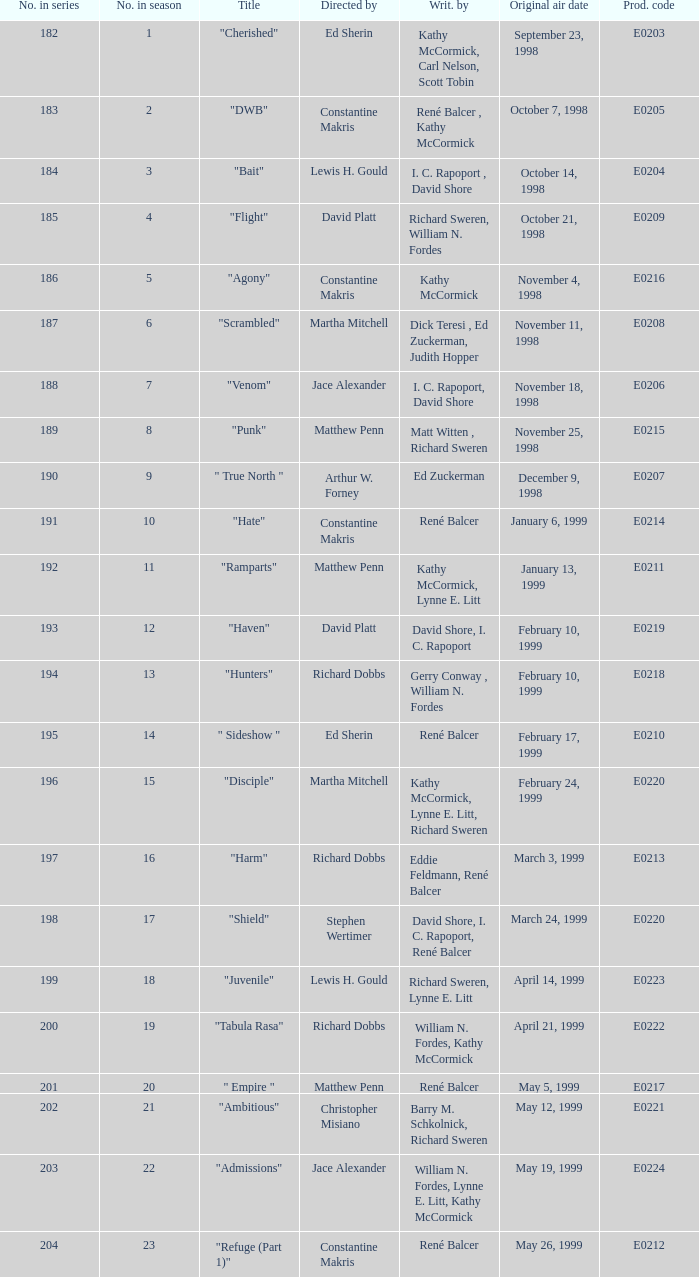The episode with the original air date January 6, 1999, has what production code? E0214. 